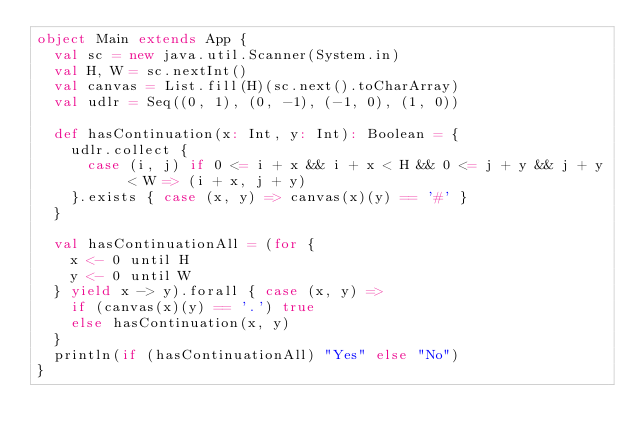<code> <loc_0><loc_0><loc_500><loc_500><_Scala_>object Main extends App {
  val sc = new java.util.Scanner(System.in)
  val H, W = sc.nextInt()
  val canvas = List.fill(H)(sc.next().toCharArray)
  val udlr = Seq((0, 1), (0, -1), (-1, 0), (1, 0))

  def hasContinuation(x: Int, y: Int): Boolean = {
    udlr.collect {
      case (i, j) if 0 <= i + x && i + x < H && 0 <= j + y && j + y < W => (i + x, j + y)
    }.exists { case (x, y) => canvas(x)(y) == '#' }
  }

  val hasContinuationAll = (for {
    x <- 0 until H
    y <- 0 until W
  } yield x -> y).forall { case (x, y) =>
    if (canvas(x)(y) == '.') true
    else hasContinuation(x, y)
  }
  println(if (hasContinuationAll) "Yes" else "No")
}
</code> 